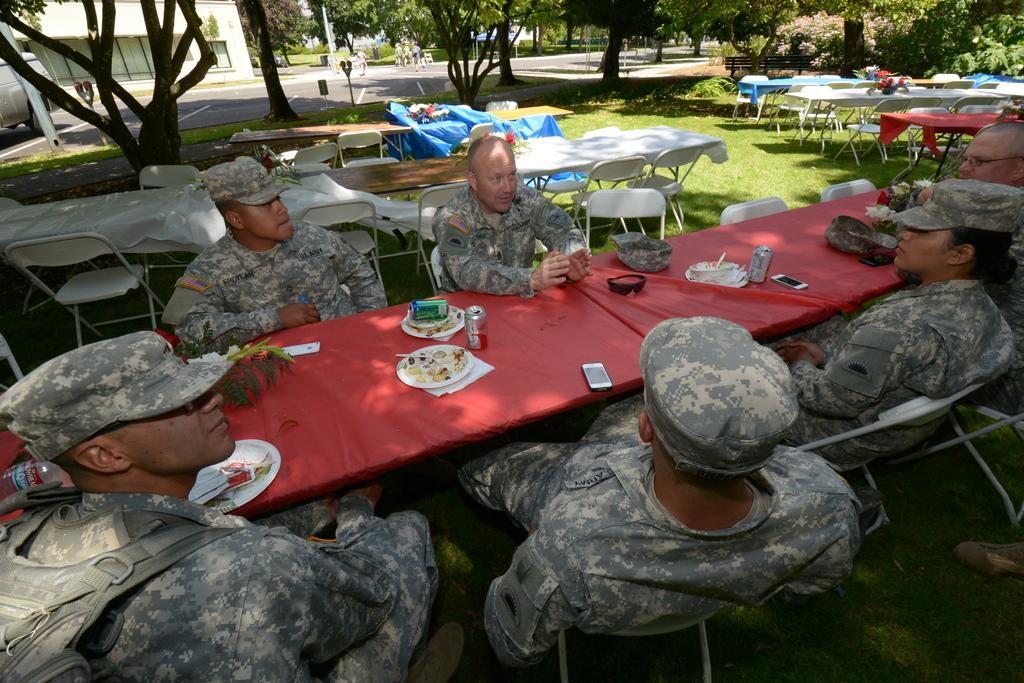Please provide a concise description of this image. In this picture we can see some people sitting on chairs in front of tables, we can see plates, tins, mobile phones on the table, in the background there are some chairs and tables, we can see grass at the bottom, we can see some trees here, we can see a building on the left side, there is a parking machine here. 